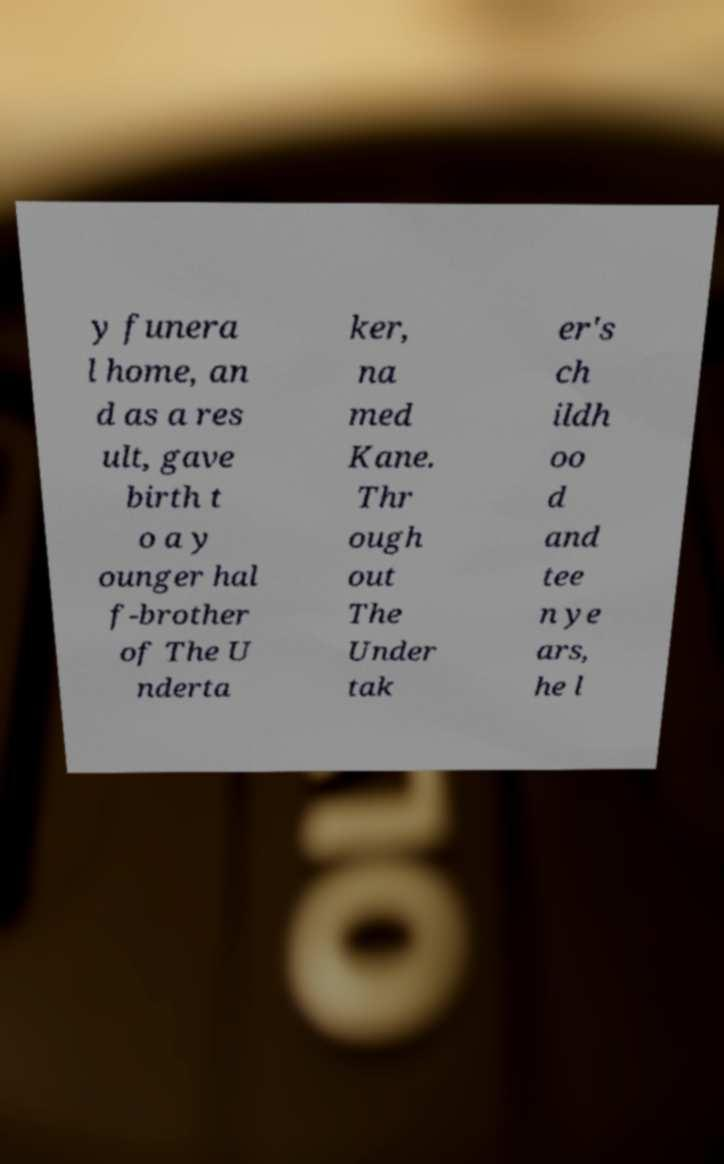Could you extract and type out the text from this image? y funera l home, an d as a res ult, gave birth t o a y ounger hal f-brother of The U nderta ker, na med Kane. Thr ough out The Under tak er's ch ildh oo d and tee n ye ars, he l 